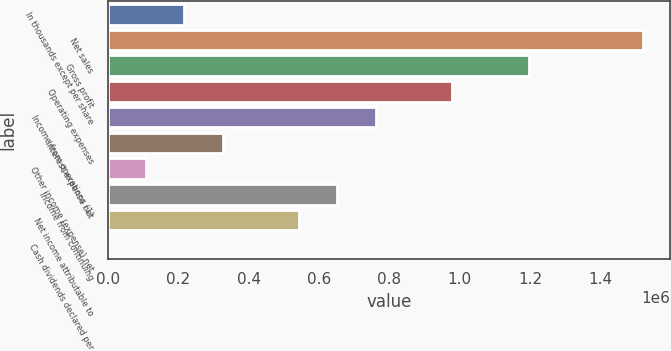Convert chart. <chart><loc_0><loc_0><loc_500><loc_500><bar_chart><fcel>In thousands except per share<fcel>Net sales<fcel>Gross profit<fcel>Operating expenses<fcel>Income from operations (1)<fcel>Interest expense net<fcel>Other income (expense) net<fcel>Income from continuing<fcel>Net income attributable to<fcel>Cash dividends declared per<nl><fcel>217524<fcel>1.52267e+06<fcel>1.19638e+06<fcel>978858<fcel>761334<fcel>326286<fcel>108762<fcel>652572<fcel>543810<fcel>0.04<nl></chart> 